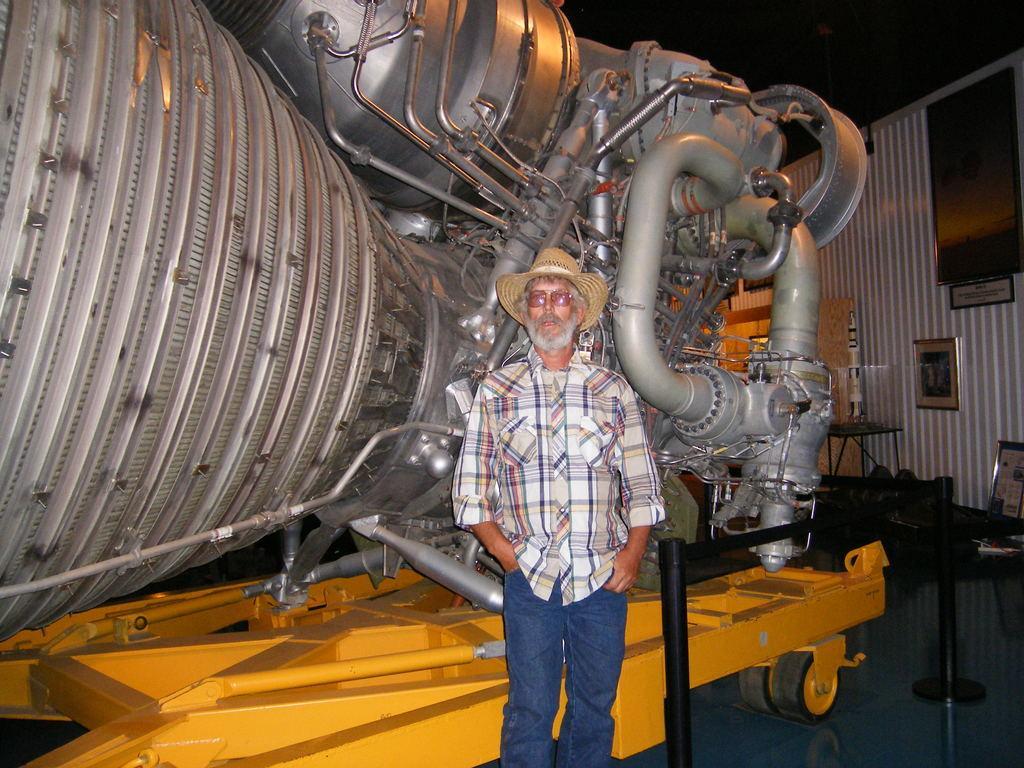How would you summarize this image in a sentence or two? In this picture I can see there is a man standing and he is wearing shirt, hat and goggles. In the backdrop there is a huge machine and there is a wall at right side. There are few chairs, tables. 